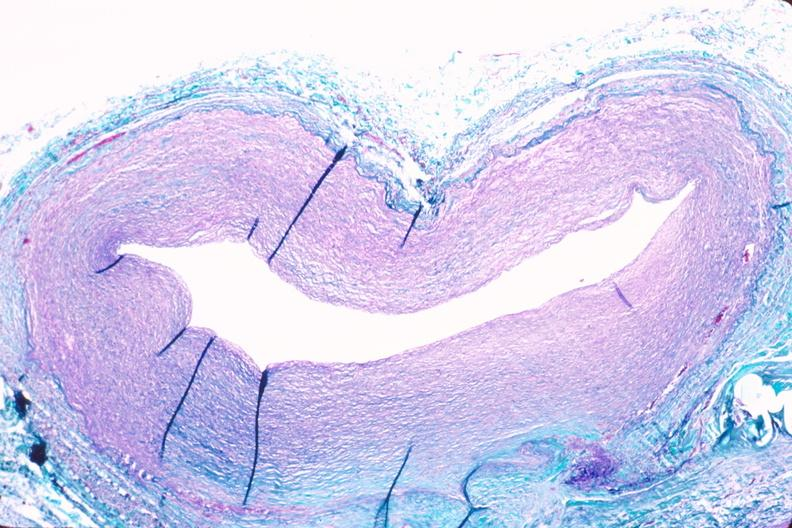s vasculature present?
Answer the question using a single word or phrase. Yes 